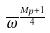Convert formula to latex. <formula><loc_0><loc_0><loc_500><loc_500>\overline { \omega } ^ { \frac { M _ { p } + 1 } { 4 } }</formula> 